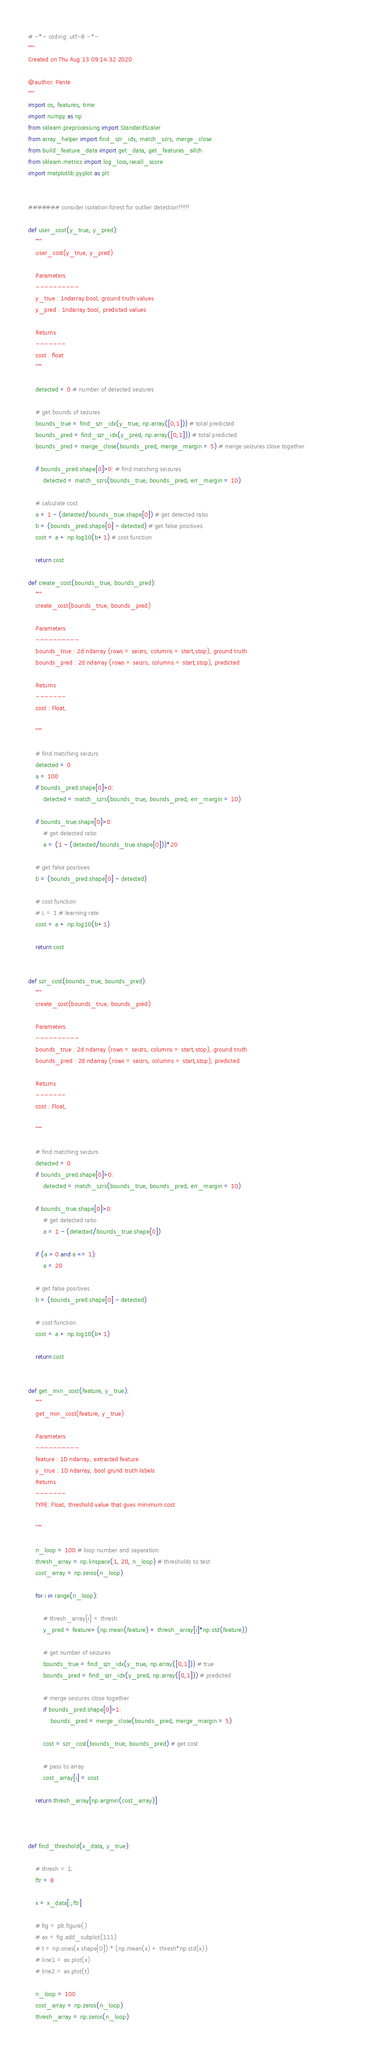<code> <loc_0><loc_0><loc_500><loc_500><_Python_># -*- coding: utf-8 -*-
"""
Created on Thu Aug 13 09:14:32 2020

@author: Pante
"""
import os, features, time
import numpy as np
from sklearn.preprocessing import StandardScaler
from array_helper import find_szr_idx, match_szrs, merge_close
from build_feature_data import get_data, get_features_allch
from sklearn.metrics import log_loss,recall_score
import matplotlib.pyplot as plt


####### consider isolation forest for outlier detection!!!!!!

def user_cost(y_true, y_pred):
    """
    user_cost(y_true, y_pred)
    
    Parameters
    ----------
    y_true : 1ndarray bool, ground truth values
    y_pred : 1ndarray bool, predicted values

    Returns
    -------
    cost : float
    """
    
    detected = 0 # number of detected seizures
    
    # get bounds of sezures
    bounds_true = find_szr_idx(y_true, np.array([0,1])) # total predicted
    bounds_pred = find_szr_idx(y_pred, np.array([0,1])) # total predicted
    bounds_pred = merge_close(bounds_pred, merge_margin = 5) # merge seizures close together                  
                    
    if bounds_pred.shape[0]>0: # find matching seizures   
        detected = match_szrs(bounds_true, bounds_pred, err_margin = 10)
     
    # calculate cost
    a = 1 - (detected/bounds_true.shape[0]) # get detected ratio 
    b = (bounds_pred.shape[0] - detected) # get false positives
    cost = a + np.log10(b+1) # cost function
    
    return cost

def create_cost(bounds_true, bounds_pred):
    """
    create_cost(bounds_true, bounds_pred)

    Parameters
    ----------
    bounds_true : 2d ndarray (rows = seizrs, columns = start,stop), ground truth
    bounds_pred : 2d ndarray (rows = seizrs, columns = start,stop), predicted

    Returns
    -------
    cost : Float,

    """

    # find matching seizurs
    detected = 0
    a = 100
    if bounds_pred.shape[0]>0:
        detected = match_szrs(bounds_true, bounds_pred, err_margin = 10)
    
    if bounds_true.shape[0]>0:
        # get detected ratio
        a = (1 - (detected/bounds_true.shape[0]))*20
        
    # get false positives
    b = (bounds_pred.shape[0] - detected)
    
    # cost function
    # L = 1 # learning rate
    cost = a + np.log10(b+1)
    
    return cost


def szr_cost(bounds_true, bounds_pred):
    """
    create_cost(bounds_true, bounds_pred)

    Parameters
    ----------
    bounds_true : 2d ndarray (rows = seizrs, columns = start,stop), ground truth
    bounds_pred : 2d ndarray (rows = seizrs, columns = start,stop), predicted

    Returns
    -------
    cost : Float,

    """

    # find matching seizurs
    detected = 0
    if bounds_pred.shape[0]>0:
        detected = match_szrs(bounds_true, bounds_pred, err_margin = 10)
    
    if bounds_true.shape[0]>0:
        # get detected ratio
        a = 1 - (detected/bounds_true.shape[0])
    
    if (a > 0 and a <= 1):
        a = 20
        
    # get false positives
    b = (bounds_pred.shape[0] - detected)
    
    # cost function
    cost = a + np.log10(b+1)
    
    return cost


def get_min_cost(feature, y_true):
    """
    get_min_cost(feature, y_true)

    Parameters
    ----------
    feature : 1D ndarray, extracted feature
    y_true : 1D ndarray, bool grund truth labels
    Returns
    -------
    TYPE: Float, threshold value that gves minimum cost

    """

    n_loop = 100 # loop number and separation
    thresh_array = np.linspace(1, 20, n_loop) # thresholds to test
    cost_array = np.zeros(n_loop)
    
    for i in range(n_loop):
        
        # thresh_array[i] = thresh  
        y_pred = feature> (np.mean(feature) + thresh_array[i]*np.std(feature))
        
        # get number of seizures
        bounds_true = find_szr_idx(y_true, np.array([0,1])) # true
        bounds_pred = find_szr_idx(y_pred, np.array([0,1])) # predicted
        
        # merge seizures close together
        if bounds_pred.shape[0]>1:
            bounds_pred = merge_close(bounds_pred, merge_margin = 5)
        
        cost = szr_cost(bounds_true, bounds_pred) # get cost
        
        # pass to array
        cost_array[i] = cost
        
    return thresh_array[np.argmin(cost_array)]



def find_threshold(x_data, y_true):
    
    # thresh = 1;
    ftr = 8
    
    x = x_data[:,ftr]
    
    # fig = plt.figure()
    # ax = fig.add_subplot(111)
    # t = np.ones(x.shape[0]) * (np.mean(x) + thresh*np.std(x))
    # line1 = ax.plot(x)
    # line2 = ax.plot(t)
    
    n_loop = 100
    cost_array = np.zeros(n_loop)
    thresh_array = np.zeros(n_loop)</code> 